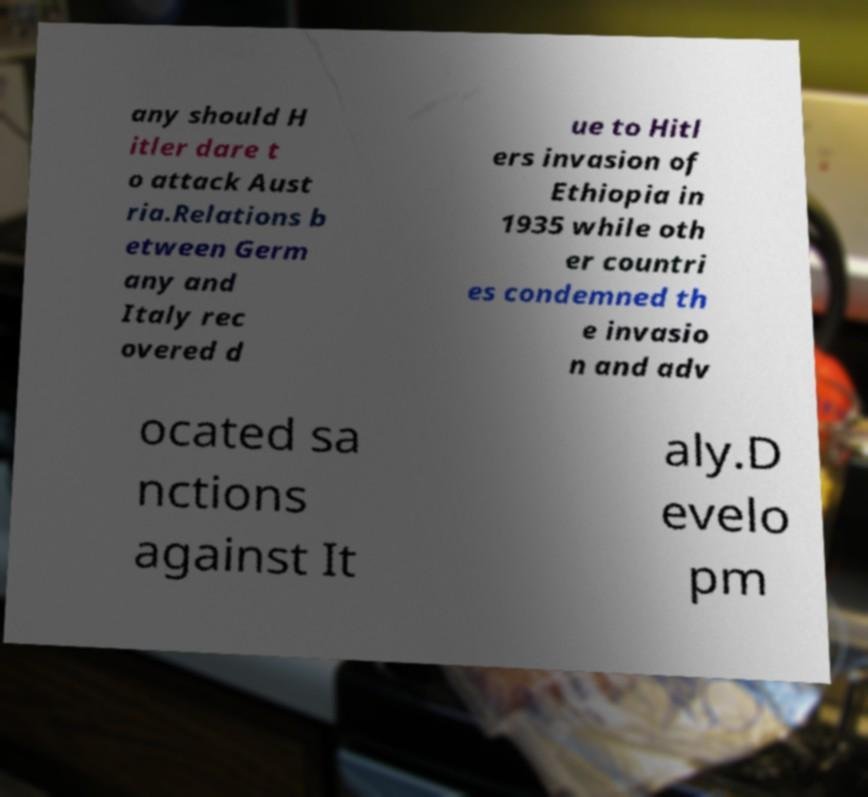Could you assist in decoding the text presented in this image and type it out clearly? any should H itler dare t o attack Aust ria.Relations b etween Germ any and Italy rec overed d ue to Hitl ers invasion of Ethiopia in 1935 while oth er countri es condemned th e invasio n and adv ocated sa nctions against It aly.D evelo pm 